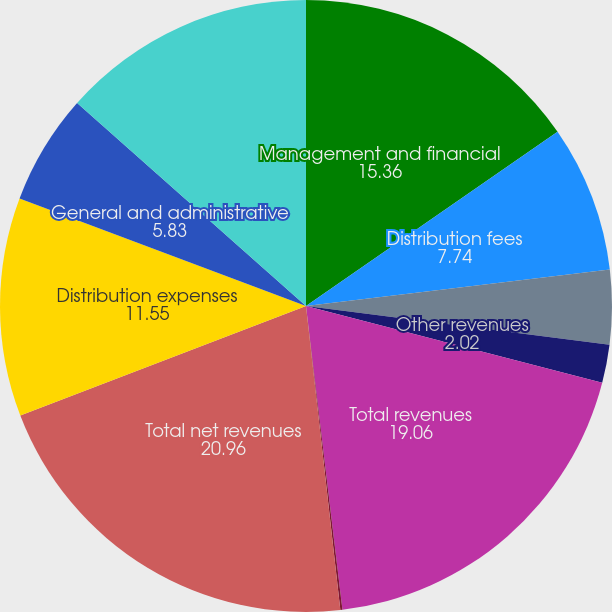Convert chart to OTSL. <chart><loc_0><loc_0><loc_500><loc_500><pie_chart><fcel>Management and financial<fcel>Distribution fees<fcel>Net investment income<fcel>Other revenues<fcel>Total revenues<fcel>Banking and deposit interest<fcel>Total net revenues<fcel>Distribution expenses<fcel>General and administrative<fcel>Total expenses<nl><fcel>15.36%<fcel>7.74%<fcel>3.92%<fcel>2.02%<fcel>19.06%<fcel>0.11%<fcel>20.96%<fcel>11.55%<fcel>5.83%<fcel>13.45%<nl></chart> 